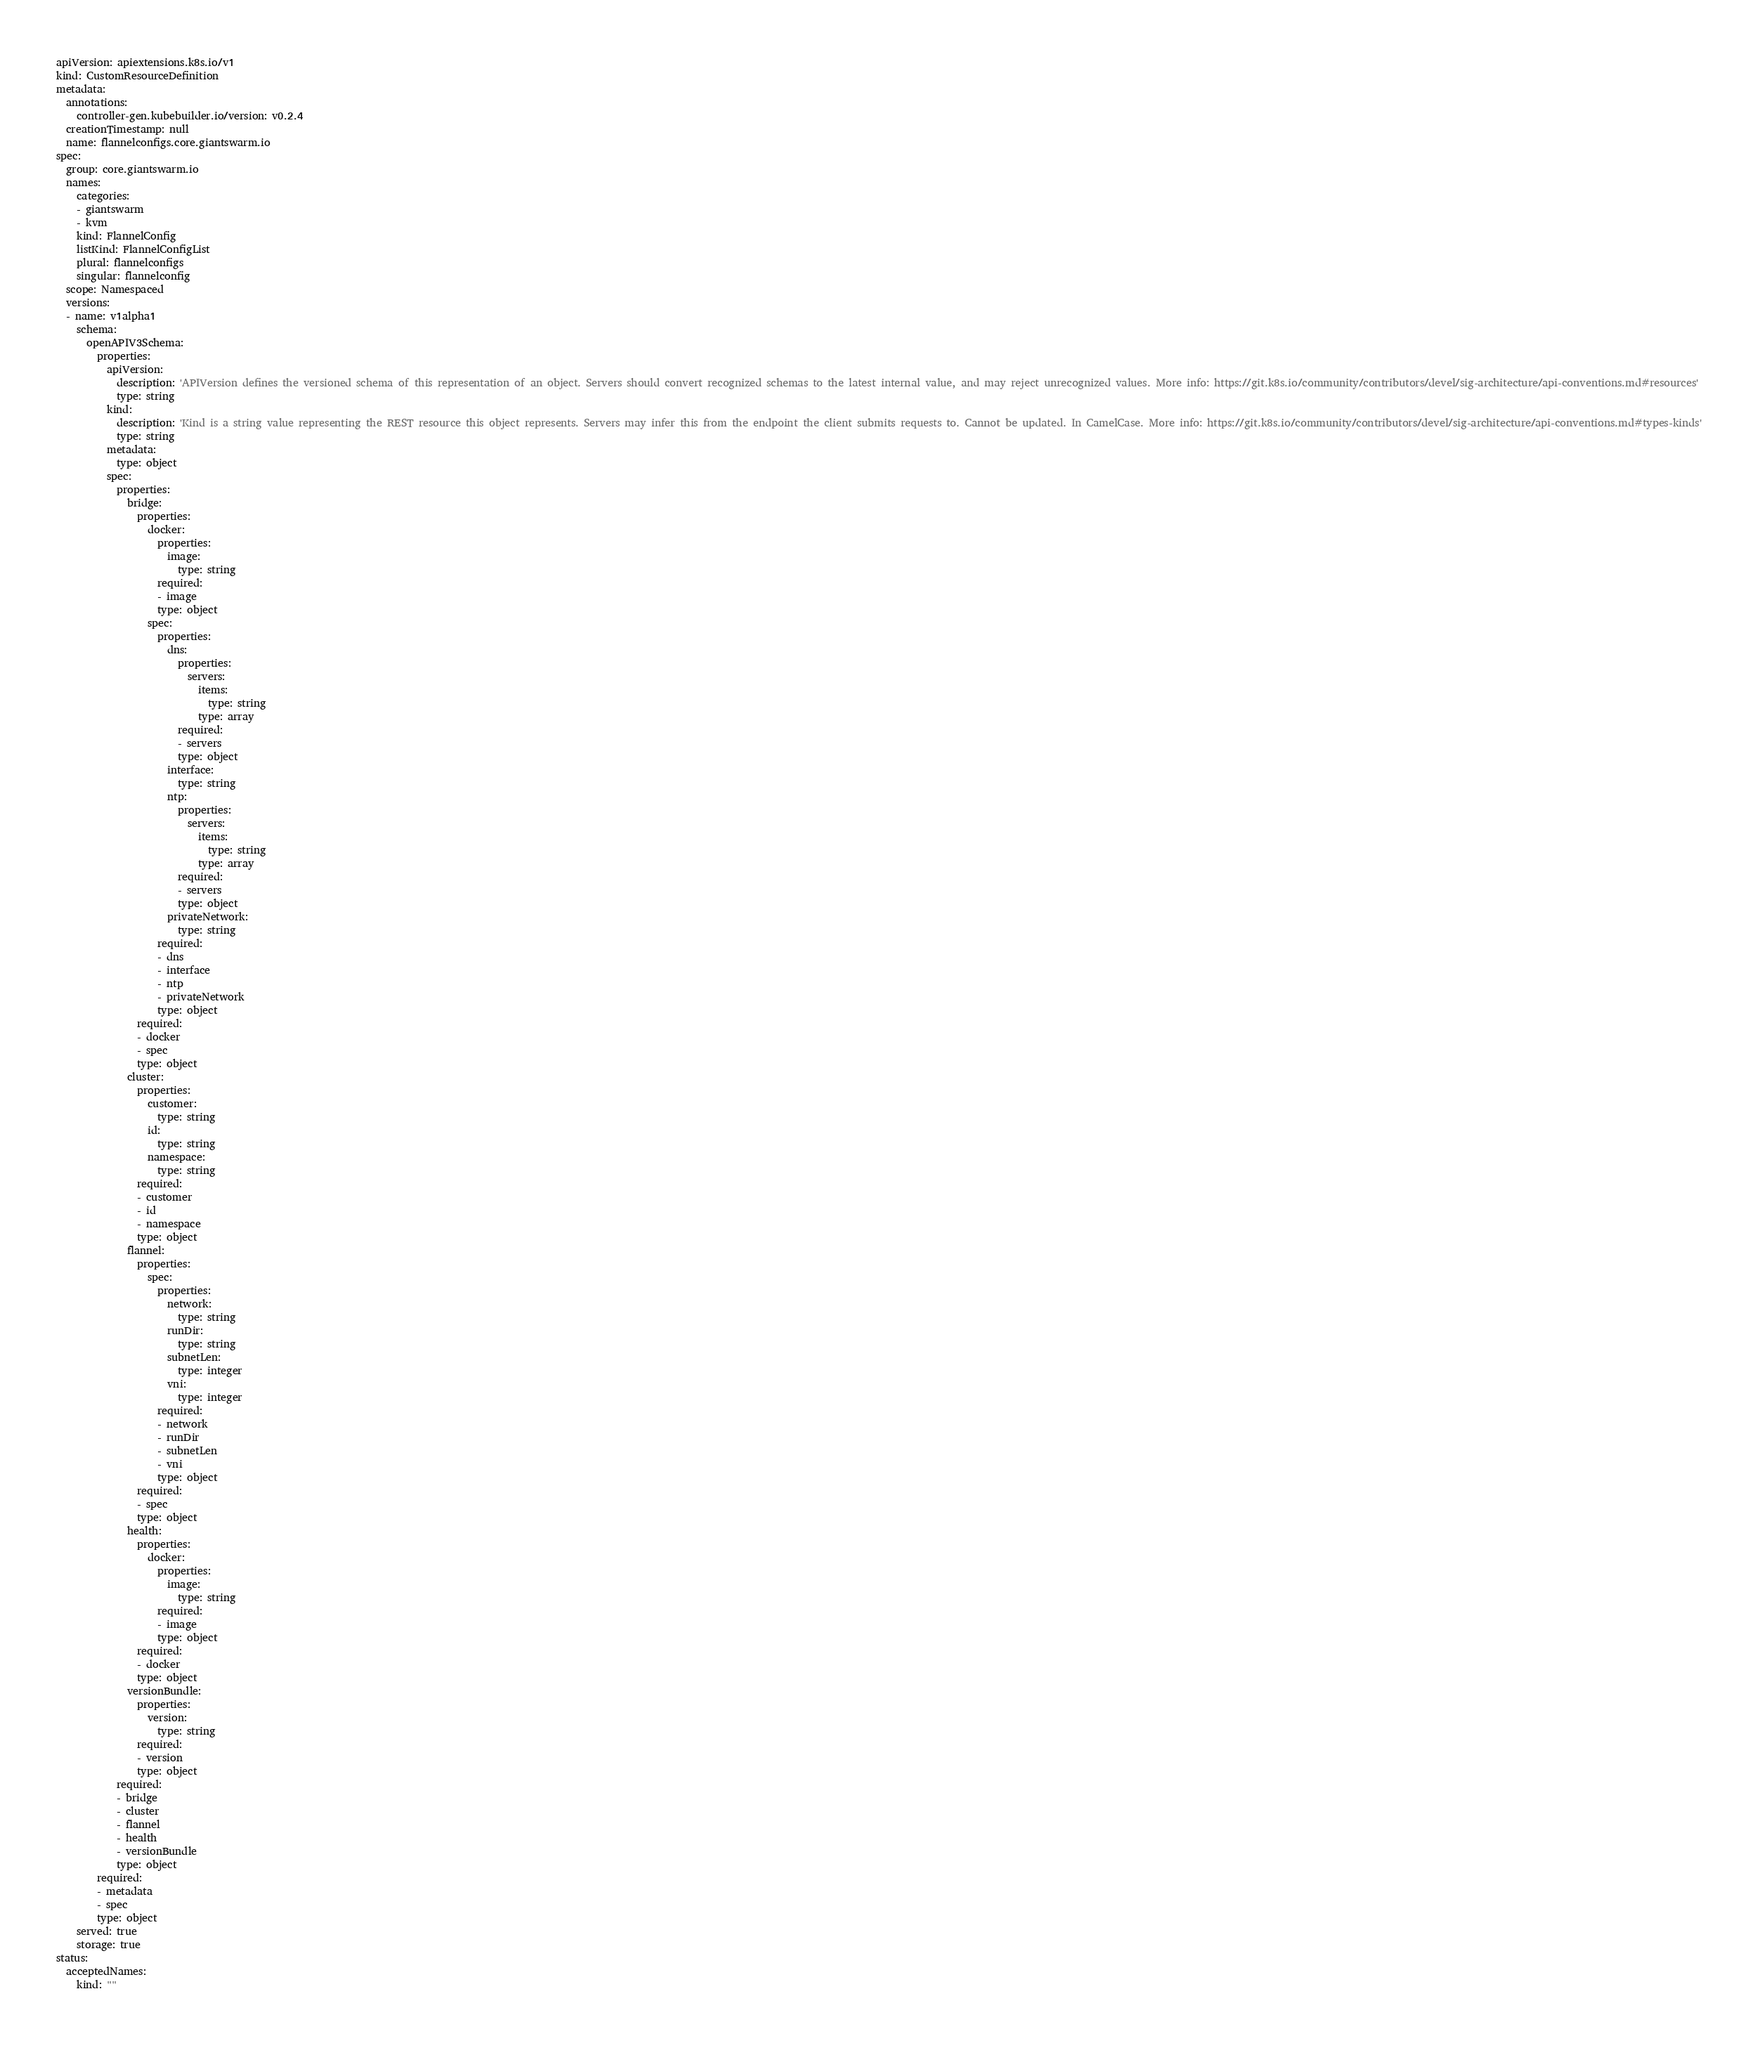Convert code to text. <code><loc_0><loc_0><loc_500><loc_500><_YAML_>apiVersion: apiextensions.k8s.io/v1
kind: CustomResourceDefinition
metadata:
  annotations:
    controller-gen.kubebuilder.io/version: v0.2.4
  creationTimestamp: null
  name: flannelconfigs.core.giantswarm.io
spec:
  group: core.giantswarm.io
  names:
    categories:
    - giantswarm
    - kvm
    kind: FlannelConfig
    listKind: FlannelConfigList
    plural: flannelconfigs
    singular: flannelconfig
  scope: Namespaced
  versions:
  - name: v1alpha1
    schema:
      openAPIV3Schema:
        properties:
          apiVersion:
            description: 'APIVersion defines the versioned schema of this representation of an object. Servers should convert recognized schemas to the latest internal value, and may reject unrecognized values. More info: https://git.k8s.io/community/contributors/devel/sig-architecture/api-conventions.md#resources'
            type: string
          kind:
            description: 'Kind is a string value representing the REST resource this object represents. Servers may infer this from the endpoint the client submits requests to. Cannot be updated. In CamelCase. More info: https://git.k8s.io/community/contributors/devel/sig-architecture/api-conventions.md#types-kinds'
            type: string
          metadata:
            type: object
          spec:
            properties:
              bridge:
                properties:
                  docker:
                    properties:
                      image:
                        type: string
                    required:
                    - image
                    type: object
                  spec:
                    properties:
                      dns:
                        properties:
                          servers:
                            items:
                              type: string
                            type: array
                        required:
                        - servers
                        type: object
                      interface:
                        type: string
                      ntp:
                        properties:
                          servers:
                            items:
                              type: string
                            type: array
                        required:
                        - servers
                        type: object
                      privateNetwork:
                        type: string
                    required:
                    - dns
                    - interface
                    - ntp
                    - privateNetwork
                    type: object
                required:
                - docker
                - spec
                type: object
              cluster:
                properties:
                  customer:
                    type: string
                  id:
                    type: string
                  namespace:
                    type: string
                required:
                - customer
                - id
                - namespace
                type: object
              flannel:
                properties:
                  spec:
                    properties:
                      network:
                        type: string
                      runDir:
                        type: string
                      subnetLen:
                        type: integer
                      vni:
                        type: integer
                    required:
                    - network
                    - runDir
                    - subnetLen
                    - vni
                    type: object
                required:
                - spec
                type: object
              health:
                properties:
                  docker:
                    properties:
                      image:
                        type: string
                    required:
                    - image
                    type: object
                required:
                - docker
                type: object
              versionBundle:
                properties:
                  version:
                    type: string
                required:
                - version
                type: object
            required:
            - bridge
            - cluster
            - flannel
            - health
            - versionBundle
            type: object
        required:
        - metadata
        - spec
        type: object
    served: true
    storage: true
status:
  acceptedNames:
    kind: ""</code> 